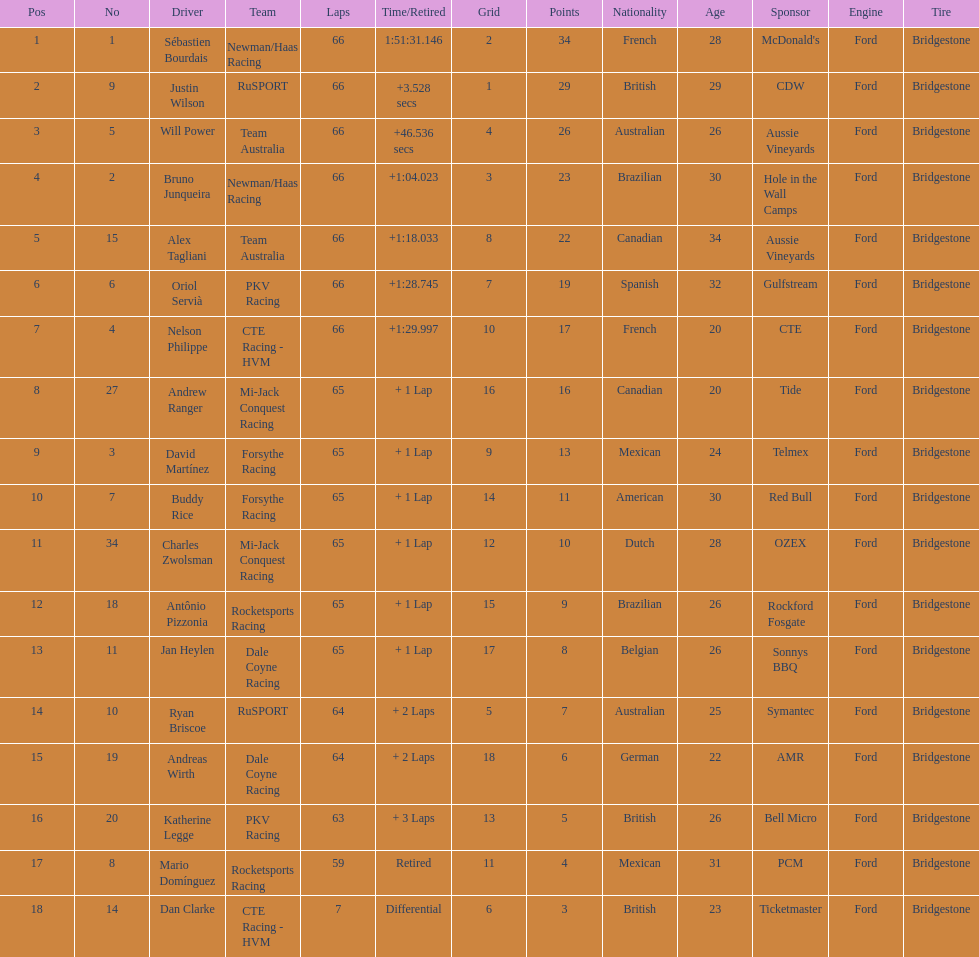At the 2006 gran premio telmex, who finished last? Dan Clarke. 